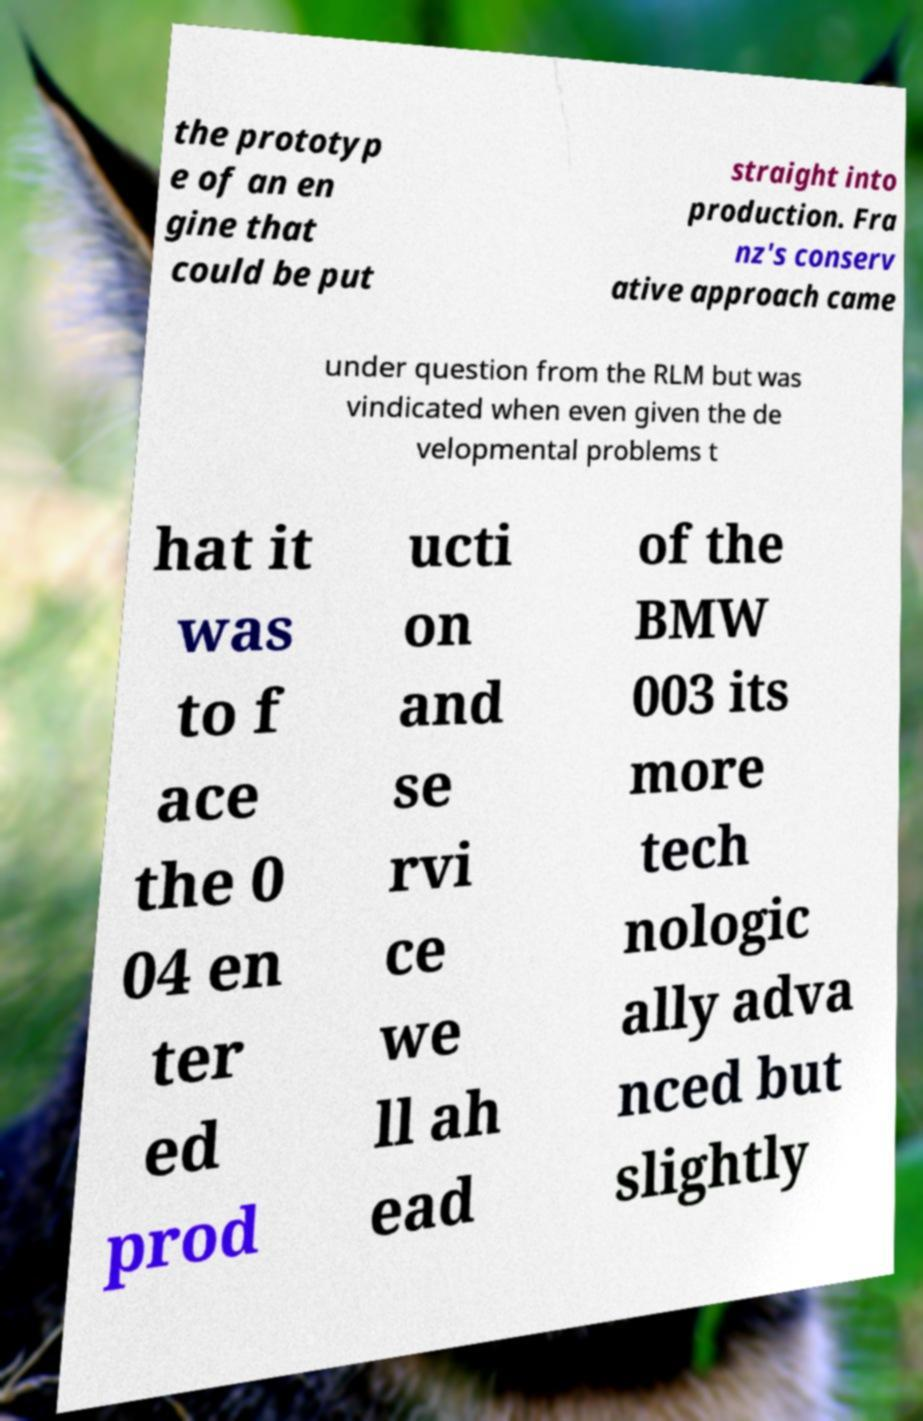I need the written content from this picture converted into text. Can you do that? the prototyp e of an en gine that could be put straight into production. Fra nz's conserv ative approach came under question from the RLM but was vindicated when even given the de velopmental problems t hat it was to f ace the 0 04 en ter ed prod ucti on and se rvi ce we ll ah ead of the BMW 003 its more tech nologic ally adva nced but slightly 